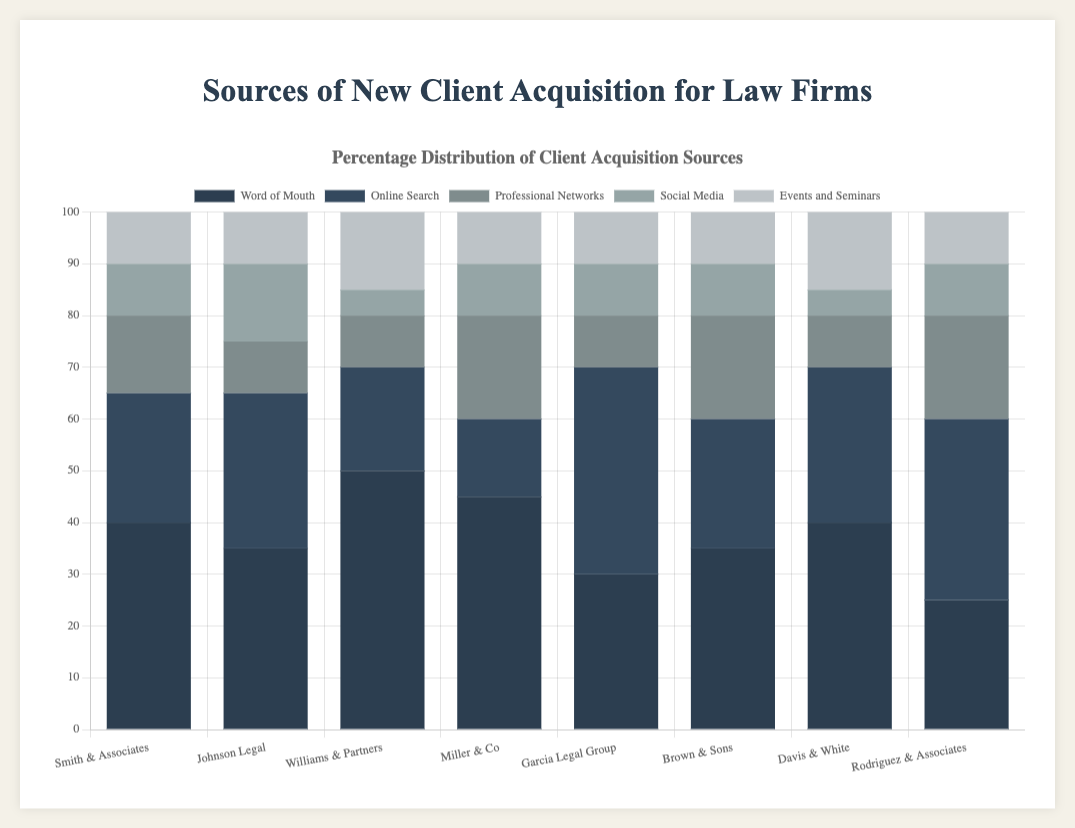What is the most common source of new client acquisition for Smith & Associates? The bar representing 'Word of Mouth' is the tallest for Smith & Associates, indicating it is the most common source.
Answer: Word of Mouth Which law firm has the highest number of clients acquired through online searches? Comparing the heights of the 'Online Search' bars, Garcia Legal Group has the tallest bar, meaning it has the most clients acquired through online searches.
Answer: Garcia Legal Group What's the total number of new clients acquired through social media for Johnson Legal and Rodriguez & Associates combined? For Johnson Legal, the social media figure is 15; for Rodriguez & Associates, it is 10. Adding these gives 15 + 10 = 25.
Answer: 25 Which law firm has the least reliance on word-of-mouth for client acquisition? The shortest 'Word of Mouth' bar belongs to Rodriguez & Associates, indicating the least reliance on this source.
Answer: Rodriguez & Associates What is the average number of clients acquired through professional networks across all firms? Add the numbers: 15 (Smith & Associates) + 10 (Johnson Legal) + 10 (Williams & Partners) + 20 (Miller & Co) + 10 (Garcia Legal Group) + 20 (Brown & Sons) + 10 (Davis & White) + 20 (Rodriguez & Associates) = 115. Divide by the number of firms: 115 / 8 = 14.375.
Answer: 14.375 Which two law firms acquired the same number of clients through events and seminars? By observing the heights, Johnson Legal and Rodriguez & Associates both have a figure of 10 for events and seminars.
Answer: Johnson Legal and Rodriguez & Associates What's the difference in the number of clients acquired via professional networks between Miller & Co and Smith & Associates? Miller & Co has 20 clients via professional networks, while Smith & Associates has 15. The difference is 20 - 15 = 5.
Answer: 5 What is the total number of clients acquired through word-of-mouth across all law firms? Sum the numbers: 40 (Smith & Associates) + 35 (Johnson Legal) + 50 (Williams & Partners) + 45 (Miller & Co) + 30 (Garcia Legal Group) + 35 (Brown & Sons) + 40 (Davis & White) + 25 (Rodriguez & Associates) = 300.
Answer: 300 Which law firm has the most diverse sources of new client acquisitions? A diverse source implies a more balanced distribution among categories. Miller & Co has relatively closer numbers for each category, indicating diversity.
Answer: Miller & Co 